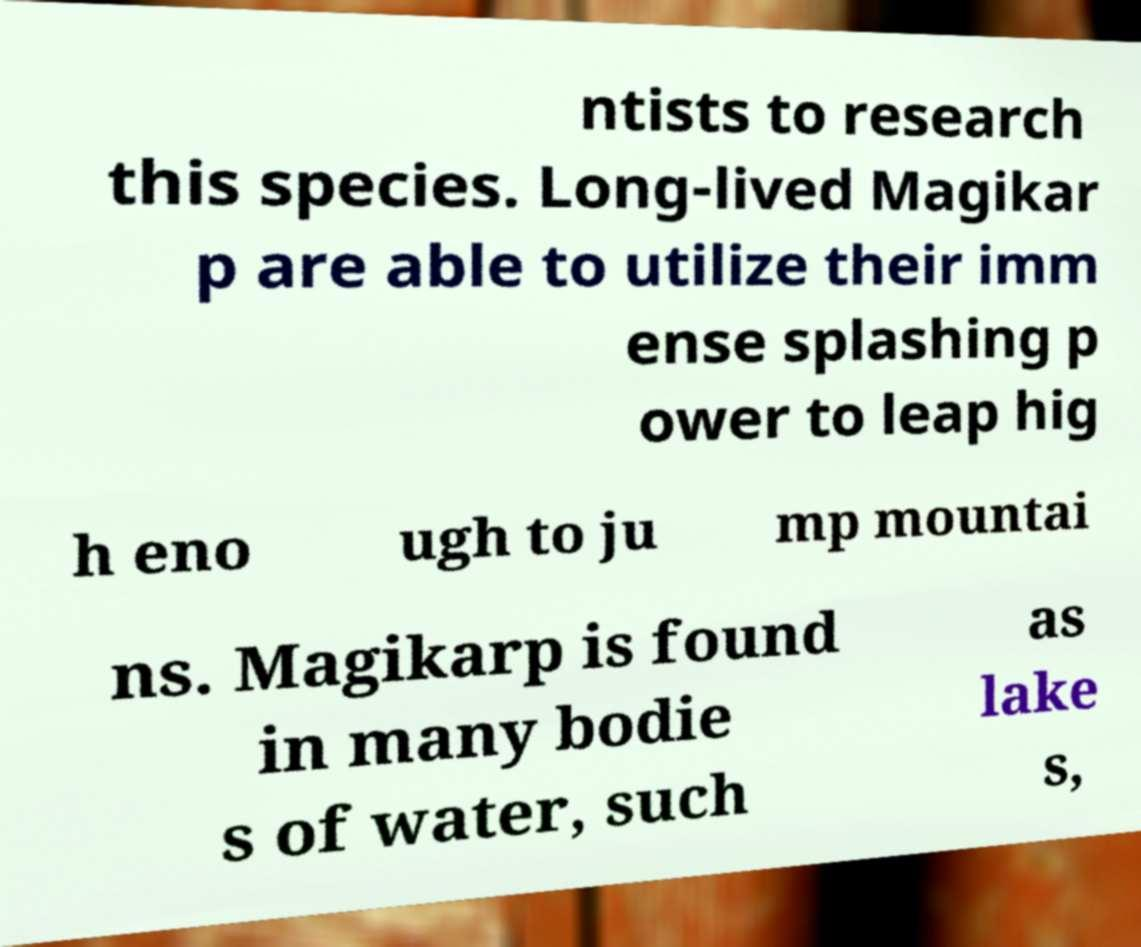Please read and relay the text visible in this image. What does it say? ntists to research this species. Long-lived Magikar p are able to utilize their imm ense splashing p ower to leap hig h eno ugh to ju mp mountai ns. Magikarp is found in many bodie s of water, such as lake s, 